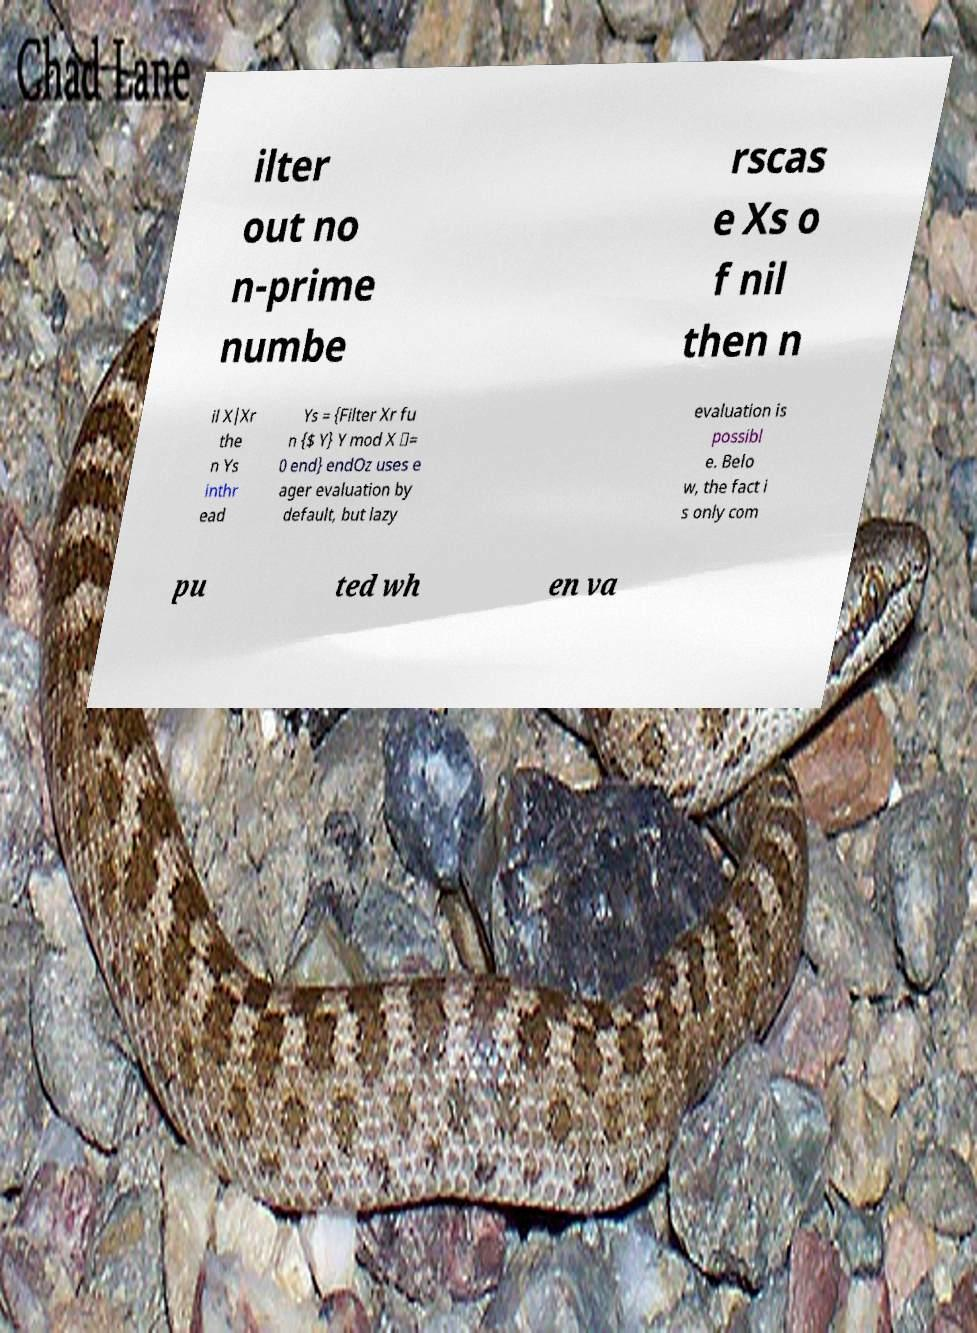There's text embedded in this image that I need extracted. Can you transcribe it verbatim? ilter out no n-prime numbe rscas e Xs o f nil then n il X|Xr the n Ys inthr ead Ys = {Filter Xr fu n {$ Y} Y mod X \= 0 end} endOz uses e ager evaluation by default, but lazy evaluation is possibl e. Belo w, the fact i s only com pu ted wh en va 